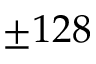<formula> <loc_0><loc_0><loc_500><loc_500>\pm 1 2 8</formula> 